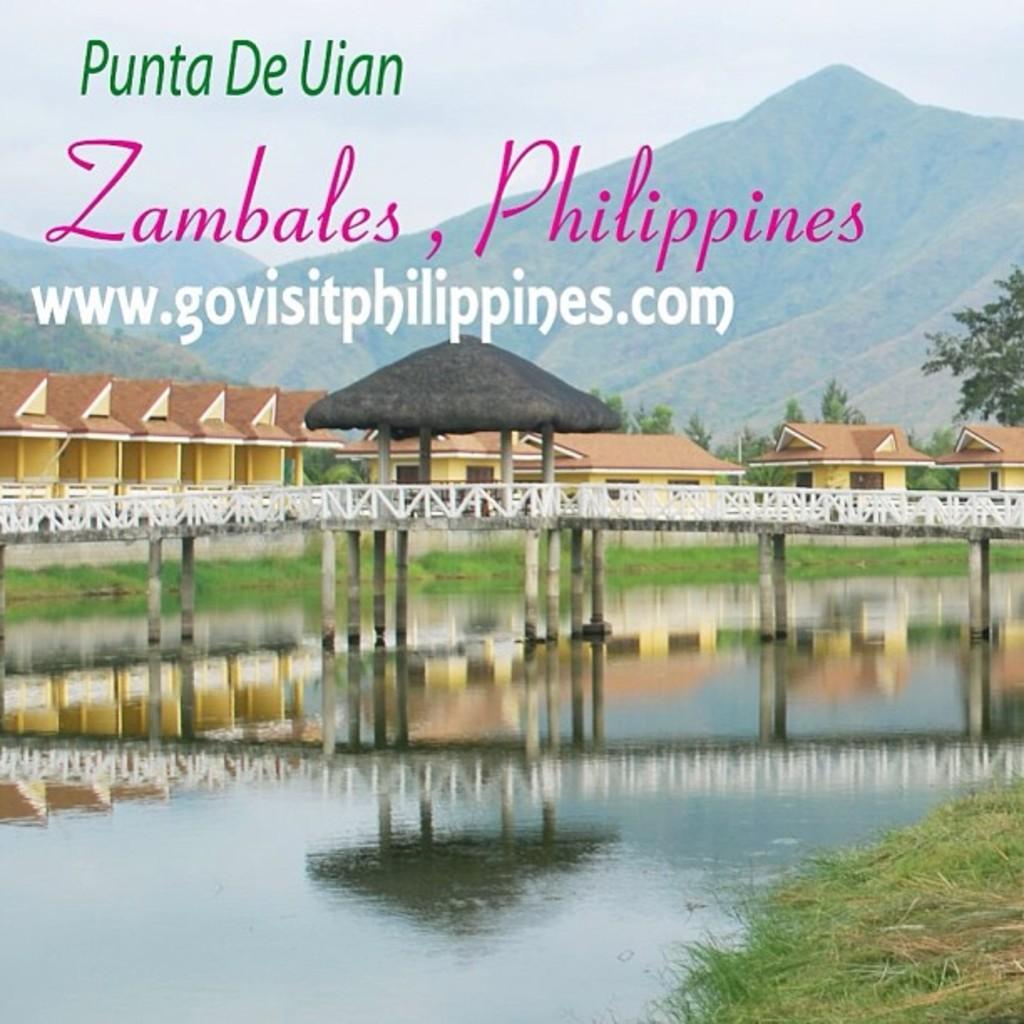Please provide a concise description of this image. At the bottom of the image there is water and grass. In the center there is a bridge and we can see a shed on the bridge. In the background there are buildings, trees, hills and sky and there is text. 